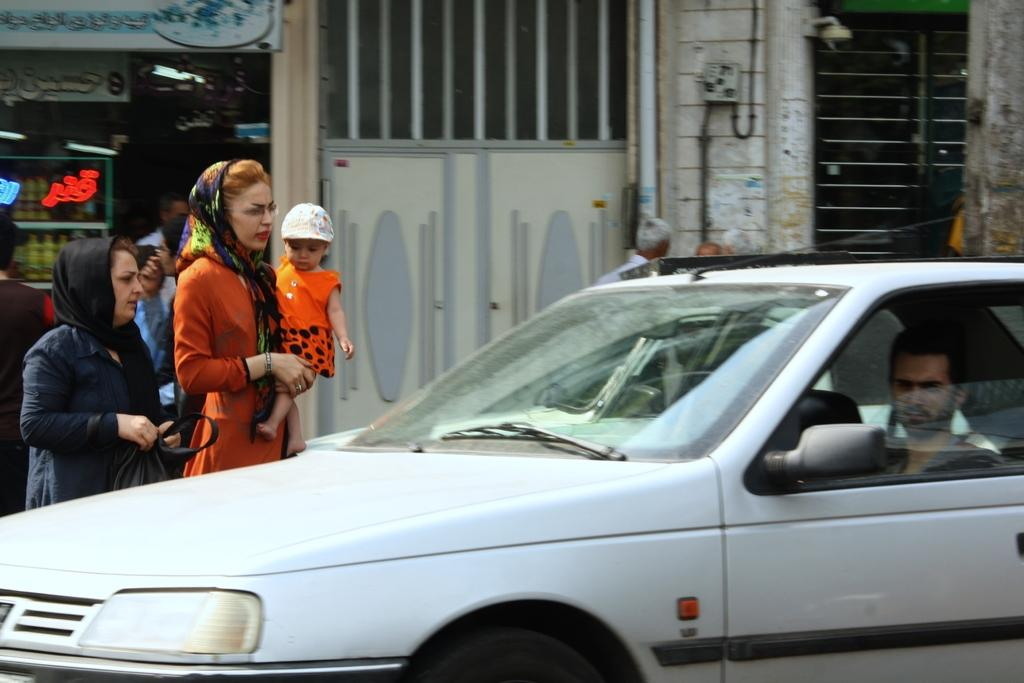What is the main subject of the image? There is a car in the image. Who else is present in the image besides the car? Two women and a baby are present in the image. What are the women and the baby doing in the image? The women and the baby are trying to cross the road. What type of wealth is visible in the image? There is no visible wealth in the image; it features a car, two women, a baby, and their attempt to cross the road. What kind of marble can be seen in the image? There is no marble present in the image. 